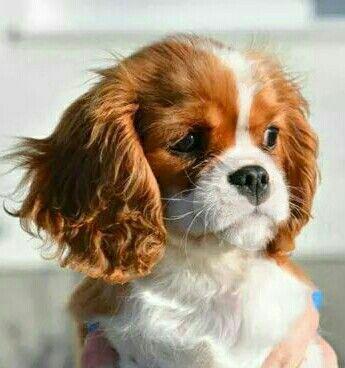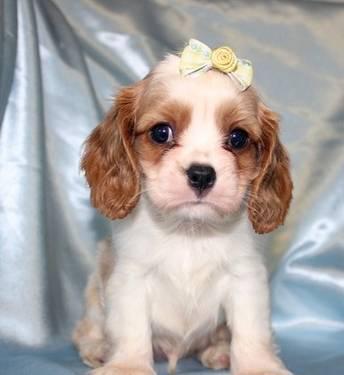The first image is the image on the left, the second image is the image on the right. Examine the images to the left and right. Is the description "Each image contains one 'real' live spaniel with dry orange-and-white fur, and one dog is posed on folds of pale fabric." accurate? Answer yes or no. Yes. The first image is the image on the left, the second image is the image on the right. Analyze the images presented: Is the assertion "A person is holding the dog in the image on the right." valid? Answer yes or no. No. 